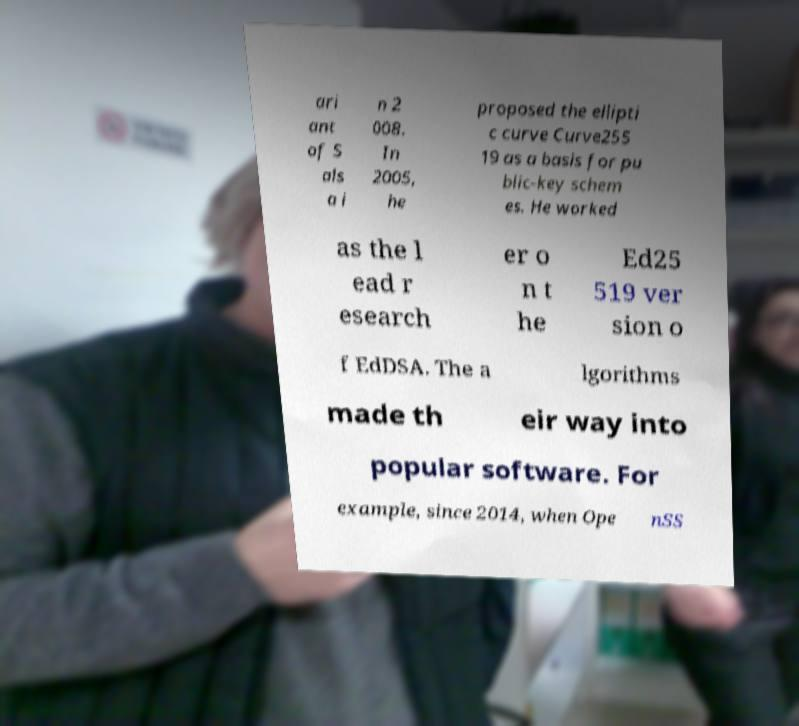Could you extract and type out the text from this image? ari ant of S als a i n 2 008. In 2005, he proposed the ellipti c curve Curve255 19 as a basis for pu blic-key schem es. He worked as the l ead r esearch er o n t he Ed25 519 ver sion o f EdDSA. The a lgorithms made th eir way into popular software. For example, since 2014, when Ope nSS 